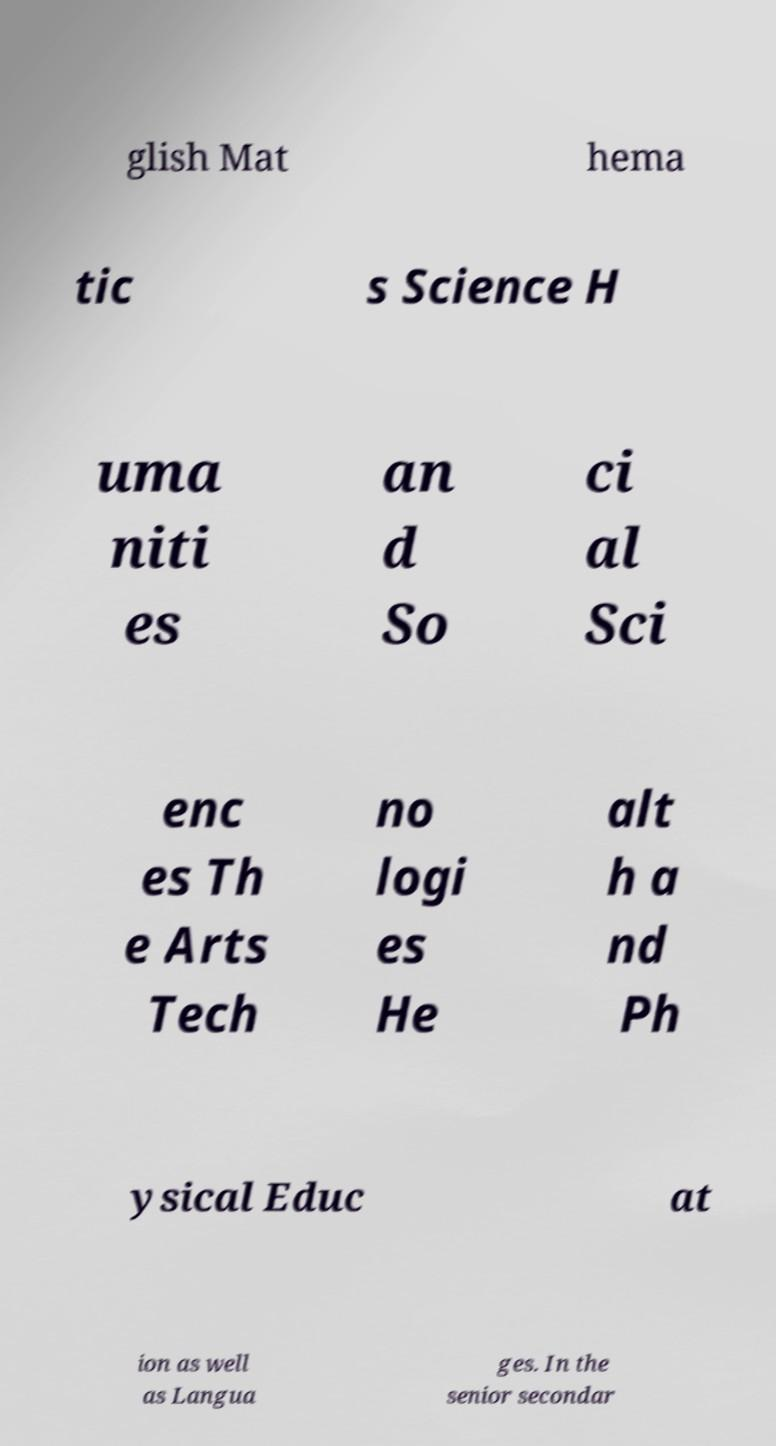For documentation purposes, I need the text within this image transcribed. Could you provide that? glish Mat hema tic s Science H uma niti es an d So ci al Sci enc es Th e Arts Tech no logi es He alt h a nd Ph ysical Educ at ion as well as Langua ges. In the senior secondar 